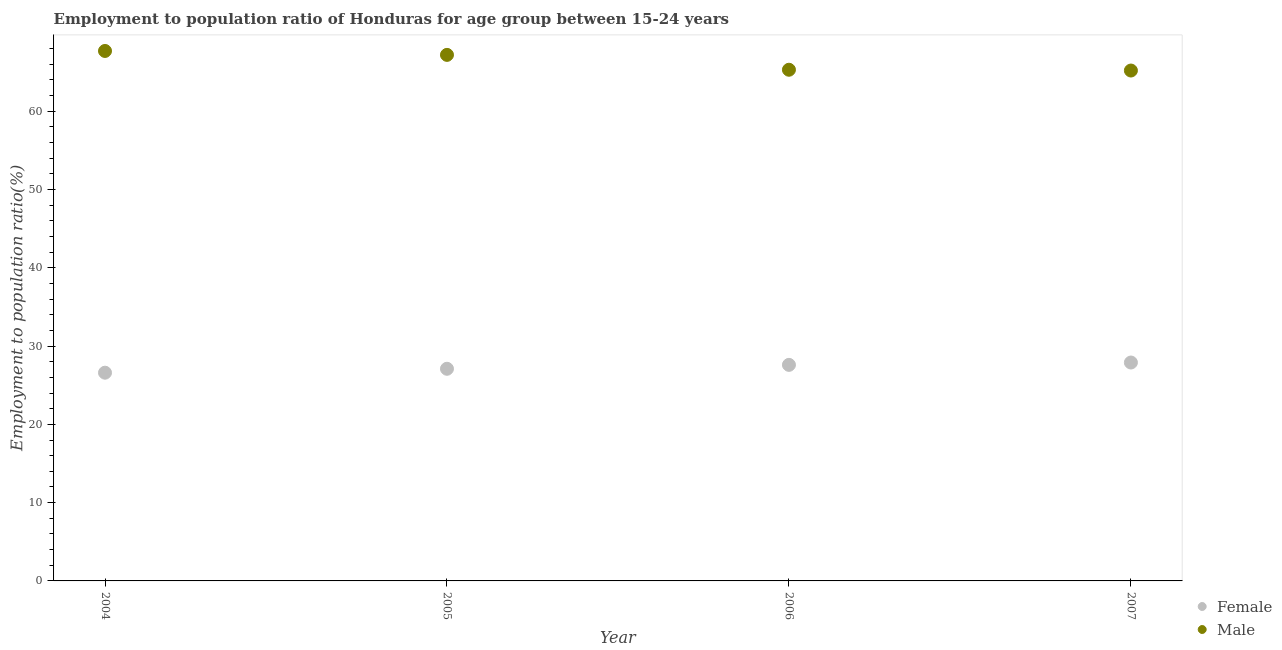How many different coloured dotlines are there?
Offer a very short reply. 2. What is the employment to population ratio(female) in 2004?
Provide a short and direct response. 26.6. Across all years, what is the maximum employment to population ratio(female)?
Provide a short and direct response. 27.9. Across all years, what is the minimum employment to population ratio(male)?
Offer a very short reply. 65.2. In which year was the employment to population ratio(male) maximum?
Give a very brief answer. 2004. In which year was the employment to population ratio(male) minimum?
Your response must be concise. 2007. What is the total employment to population ratio(male) in the graph?
Provide a succinct answer. 265.4. What is the difference between the employment to population ratio(female) in 2007 and the employment to population ratio(male) in 2005?
Offer a terse response. -39.3. What is the average employment to population ratio(male) per year?
Your response must be concise. 66.35. In the year 2004, what is the difference between the employment to population ratio(male) and employment to population ratio(female)?
Provide a short and direct response. 41.1. In how many years, is the employment to population ratio(female) greater than 66 %?
Offer a very short reply. 0. What is the ratio of the employment to population ratio(female) in 2006 to that in 2007?
Your response must be concise. 0.99. What is the difference between the highest and the second highest employment to population ratio(female)?
Give a very brief answer. 0.3. What is the difference between the highest and the lowest employment to population ratio(female)?
Your response must be concise. 1.3. Does the employment to population ratio(male) monotonically increase over the years?
Your answer should be compact. No. Is the employment to population ratio(male) strictly greater than the employment to population ratio(female) over the years?
Your answer should be very brief. Yes. Is the employment to population ratio(female) strictly less than the employment to population ratio(male) over the years?
Ensure brevity in your answer.  Yes. Are the values on the major ticks of Y-axis written in scientific E-notation?
Offer a terse response. No. Does the graph contain any zero values?
Ensure brevity in your answer.  No. How many legend labels are there?
Provide a succinct answer. 2. How are the legend labels stacked?
Give a very brief answer. Vertical. What is the title of the graph?
Offer a terse response. Employment to population ratio of Honduras for age group between 15-24 years. What is the Employment to population ratio(%) in Female in 2004?
Provide a succinct answer. 26.6. What is the Employment to population ratio(%) of Male in 2004?
Your answer should be very brief. 67.7. What is the Employment to population ratio(%) of Female in 2005?
Ensure brevity in your answer.  27.1. What is the Employment to population ratio(%) of Male in 2005?
Offer a terse response. 67.2. What is the Employment to population ratio(%) of Female in 2006?
Your answer should be very brief. 27.6. What is the Employment to population ratio(%) in Male in 2006?
Your response must be concise. 65.3. What is the Employment to population ratio(%) of Female in 2007?
Provide a succinct answer. 27.9. What is the Employment to population ratio(%) of Male in 2007?
Your answer should be very brief. 65.2. Across all years, what is the maximum Employment to population ratio(%) of Female?
Provide a short and direct response. 27.9. Across all years, what is the maximum Employment to population ratio(%) of Male?
Your answer should be compact. 67.7. Across all years, what is the minimum Employment to population ratio(%) of Female?
Keep it short and to the point. 26.6. Across all years, what is the minimum Employment to population ratio(%) of Male?
Your answer should be very brief. 65.2. What is the total Employment to population ratio(%) of Female in the graph?
Ensure brevity in your answer.  109.2. What is the total Employment to population ratio(%) of Male in the graph?
Keep it short and to the point. 265.4. What is the difference between the Employment to population ratio(%) of Female in 2004 and that in 2006?
Make the answer very short. -1. What is the difference between the Employment to population ratio(%) of Male in 2004 and that in 2006?
Make the answer very short. 2.4. What is the difference between the Employment to population ratio(%) of Female in 2004 and that in 2007?
Make the answer very short. -1.3. What is the difference between the Employment to population ratio(%) of Male in 2004 and that in 2007?
Offer a very short reply. 2.5. What is the difference between the Employment to population ratio(%) in Female in 2005 and that in 2007?
Offer a terse response. -0.8. What is the difference between the Employment to population ratio(%) of Male in 2005 and that in 2007?
Offer a terse response. 2. What is the difference between the Employment to population ratio(%) in Male in 2006 and that in 2007?
Offer a very short reply. 0.1. What is the difference between the Employment to population ratio(%) in Female in 2004 and the Employment to population ratio(%) in Male in 2005?
Provide a succinct answer. -40.6. What is the difference between the Employment to population ratio(%) in Female in 2004 and the Employment to population ratio(%) in Male in 2006?
Your answer should be very brief. -38.7. What is the difference between the Employment to population ratio(%) of Female in 2004 and the Employment to population ratio(%) of Male in 2007?
Your answer should be compact. -38.6. What is the difference between the Employment to population ratio(%) in Female in 2005 and the Employment to population ratio(%) in Male in 2006?
Ensure brevity in your answer.  -38.2. What is the difference between the Employment to population ratio(%) of Female in 2005 and the Employment to population ratio(%) of Male in 2007?
Offer a very short reply. -38.1. What is the difference between the Employment to population ratio(%) of Female in 2006 and the Employment to population ratio(%) of Male in 2007?
Provide a succinct answer. -37.6. What is the average Employment to population ratio(%) of Female per year?
Ensure brevity in your answer.  27.3. What is the average Employment to population ratio(%) of Male per year?
Keep it short and to the point. 66.35. In the year 2004, what is the difference between the Employment to population ratio(%) in Female and Employment to population ratio(%) in Male?
Your response must be concise. -41.1. In the year 2005, what is the difference between the Employment to population ratio(%) in Female and Employment to population ratio(%) in Male?
Ensure brevity in your answer.  -40.1. In the year 2006, what is the difference between the Employment to population ratio(%) of Female and Employment to population ratio(%) of Male?
Offer a terse response. -37.7. In the year 2007, what is the difference between the Employment to population ratio(%) in Female and Employment to population ratio(%) in Male?
Offer a terse response. -37.3. What is the ratio of the Employment to population ratio(%) in Female in 2004 to that in 2005?
Your answer should be very brief. 0.98. What is the ratio of the Employment to population ratio(%) in Male in 2004 to that in 2005?
Provide a short and direct response. 1.01. What is the ratio of the Employment to population ratio(%) of Female in 2004 to that in 2006?
Keep it short and to the point. 0.96. What is the ratio of the Employment to population ratio(%) in Male in 2004 to that in 2006?
Keep it short and to the point. 1.04. What is the ratio of the Employment to population ratio(%) of Female in 2004 to that in 2007?
Make the answer very short. 0.95. What is the ratio of the Employment to population ratio(%) in Male in 2004 to that in 2007?
Make the answer very short. 1.04. What is the ratio of the Employment to population ratio(%) in Female in 2005 to that in 2006?
Offer a terse response. 0.98. What is the ratio of the Employment to population ratio(%) in Male in 2005 to that in 2006?
Offer a very short reply. 1.03. What is the ratio of the Employment to population ratio(%) in Female in 2005 to that in 2007?
Offer a terse response. 0.97. What is the ratio of the Employment to population ratio(%) of Male in 2005 to that in 2007?
Your response must be concise. 1.03. What is the ratio of the Employment to population ratio(%) in Female in 2006 to that in 2007?
Give a very brief answer. 0.99. What is the difference between the highest and the second highest Employment to population ratio(%) of Female?
Offer a terse response. 0.3. What is the difference between the highest and the lowest Employment to population ratio(%) of Female?
Offer a terse response. 1.3. 